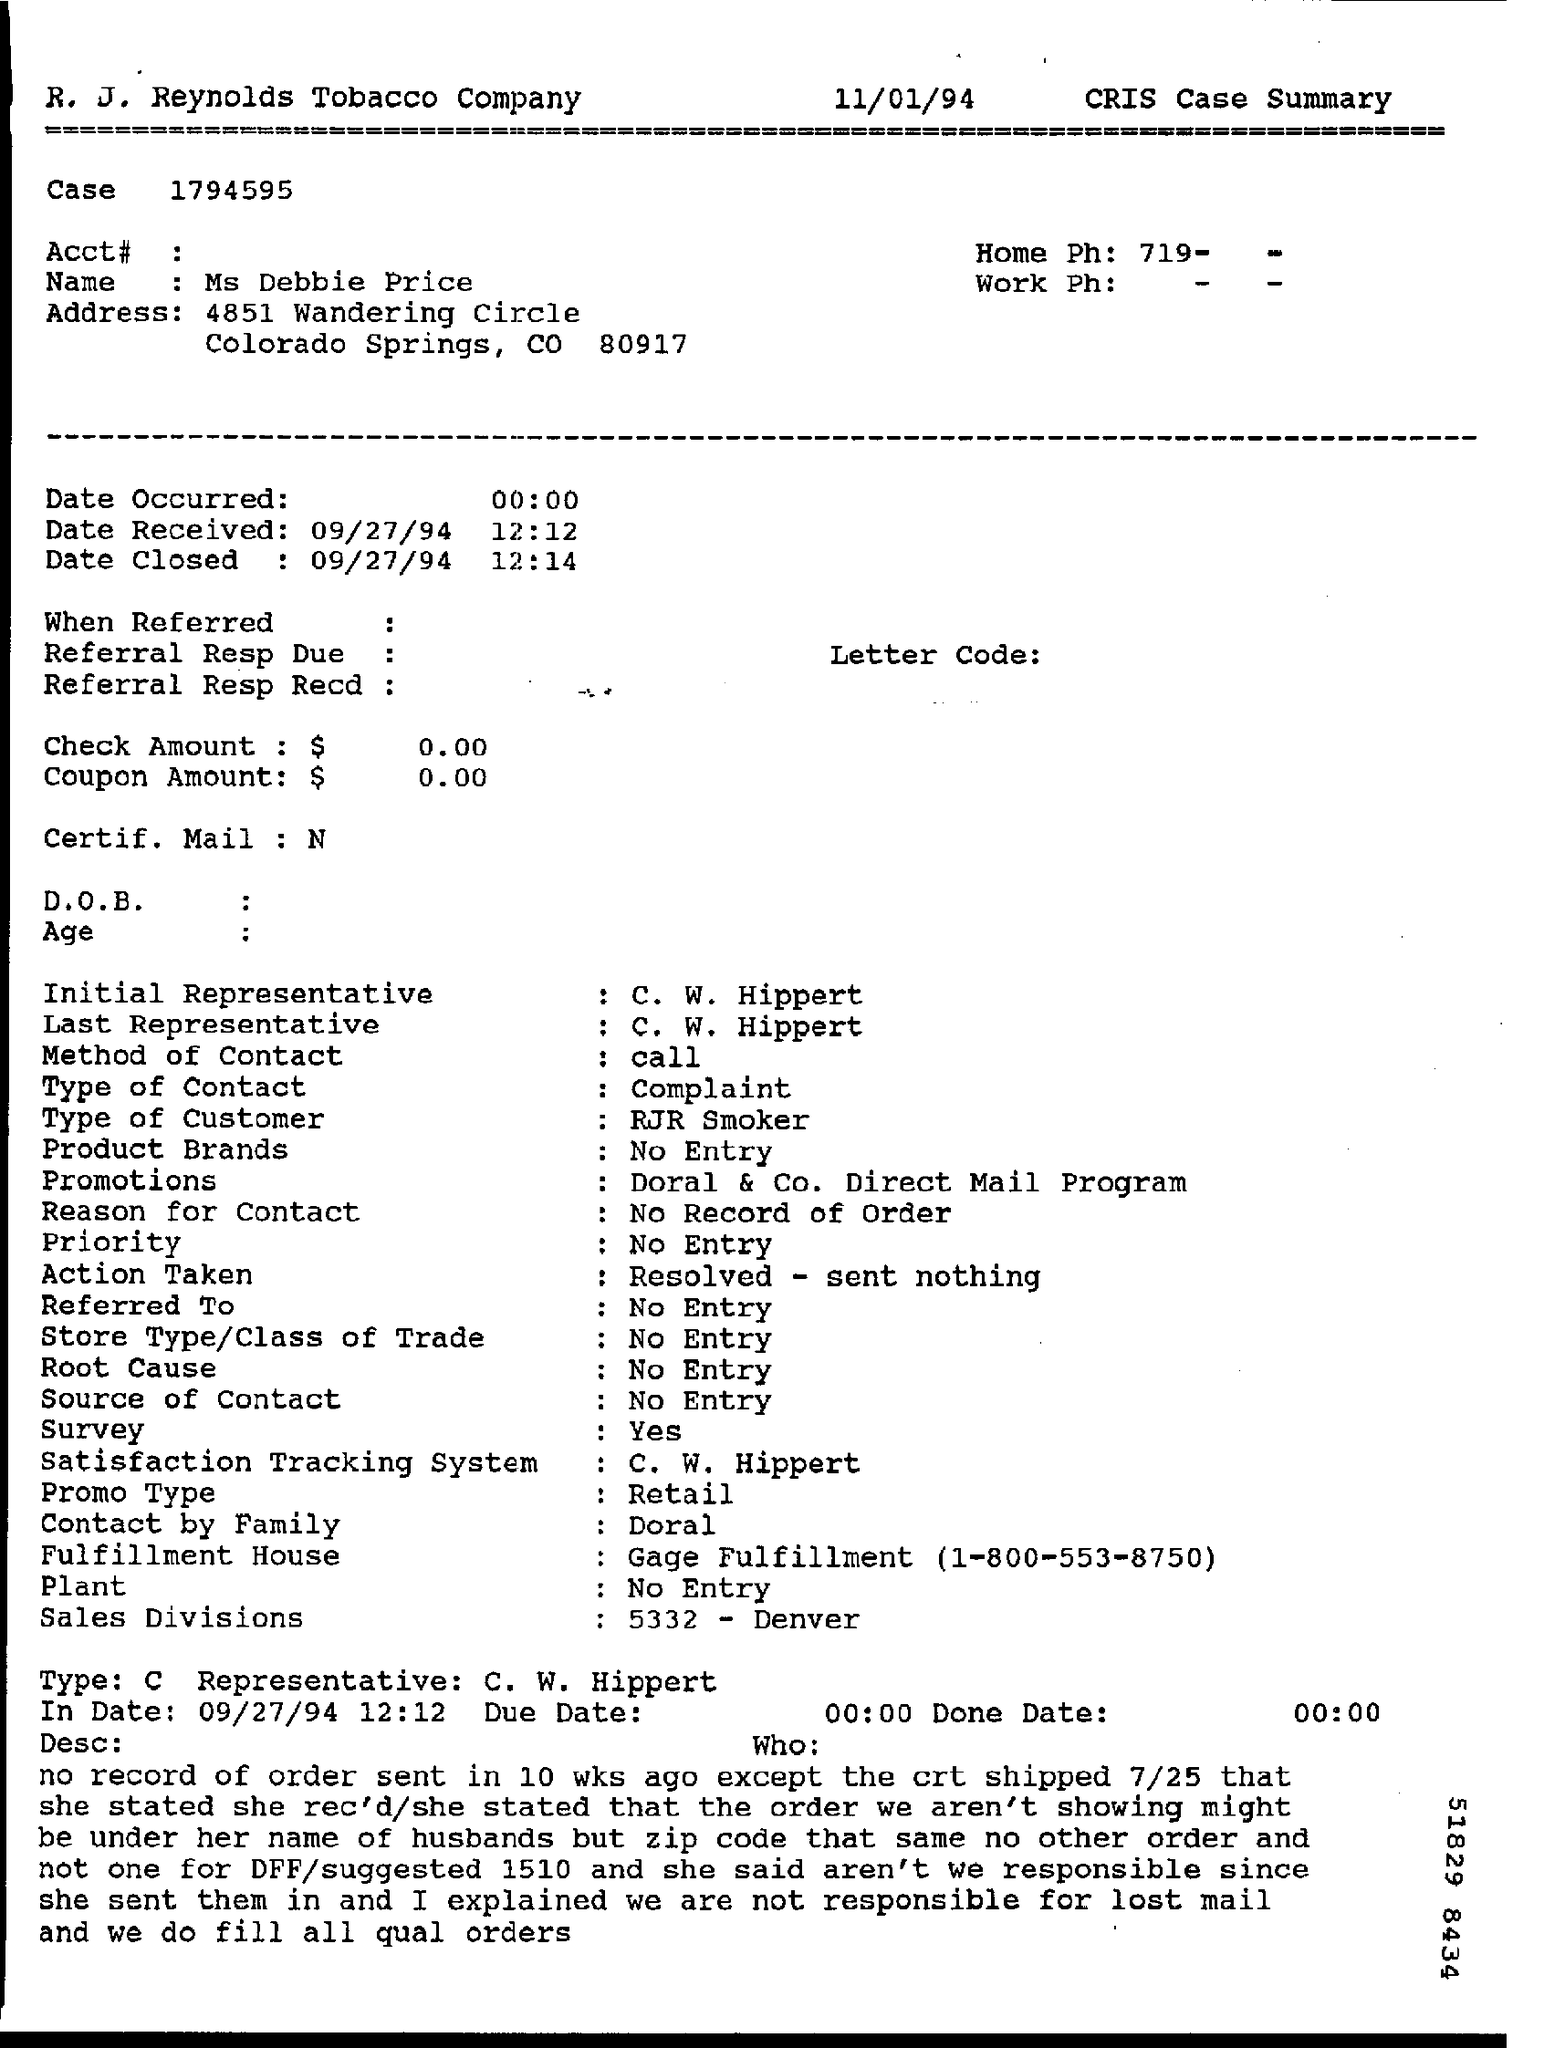Give some essential details in this illustration. The time mentioned in the IN date is 12:12. The name mentioned is MS Debbie Price. Please provide the date that was mentioned as IN date, which is 09/27/94. 